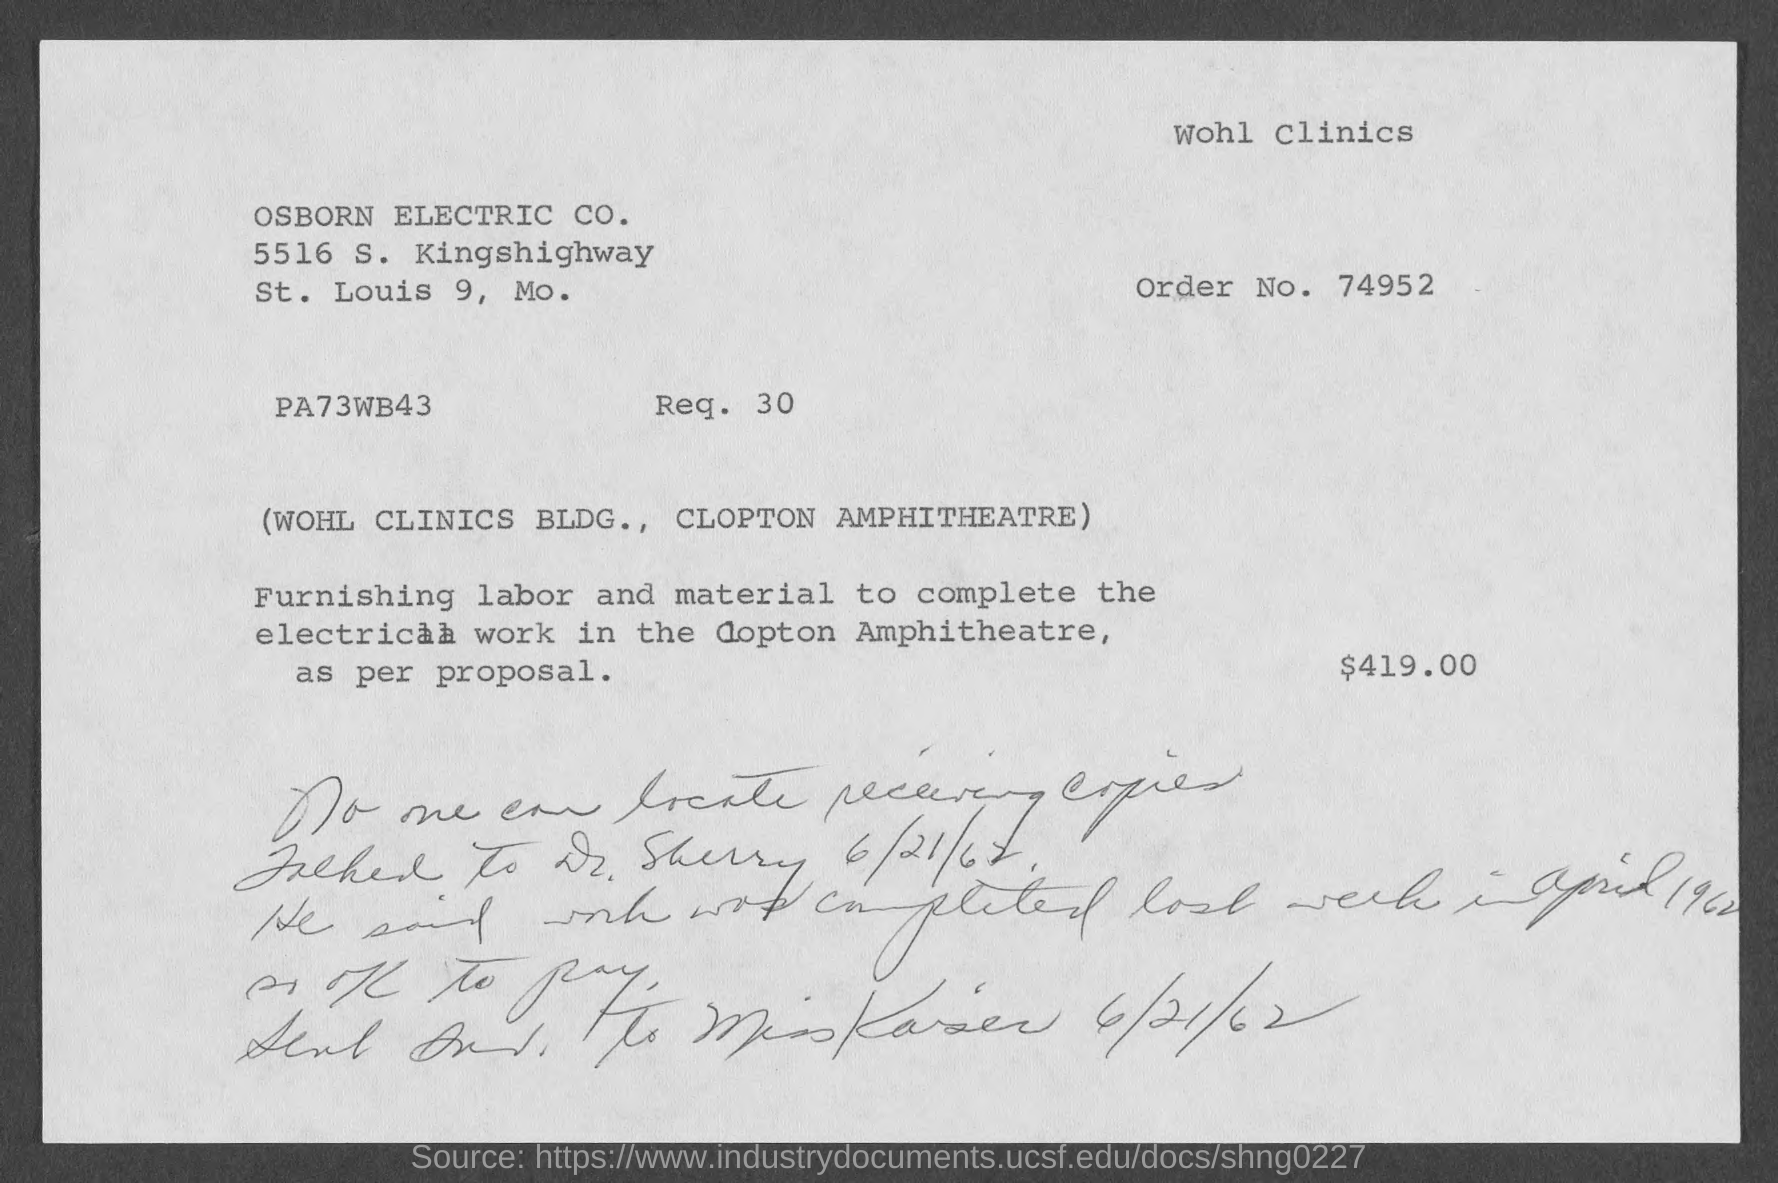Identify some key points in this picture. The street address of Osborn Electric Co. is 5516 S. Kingshighway. The order number is 74952... 